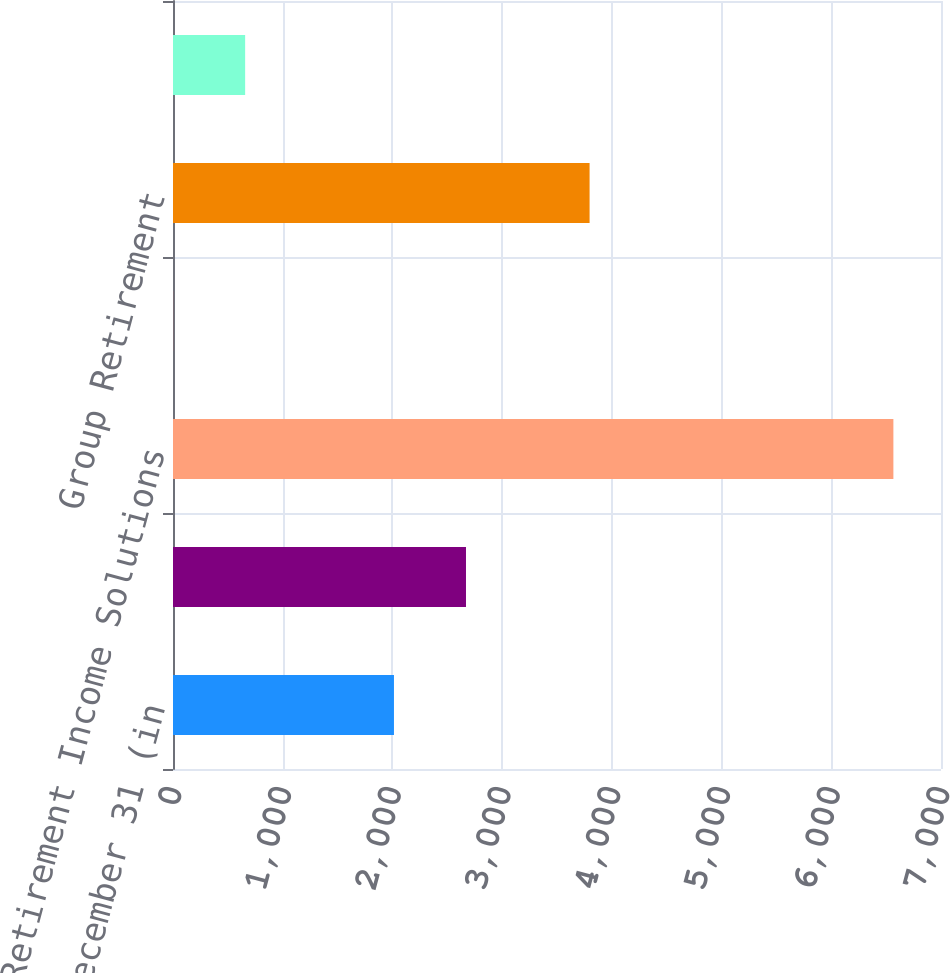Convert chart. <chart><loc_0><loc_0><loc_500><loc_500><bar_chart><fcel>Years Ended December 31 (in<fcel>Fixed Annuities<fcel>Retirement Income Solutions<fcel>Retail Mutual Funds<fcel>Group Retirement<fcel>Total Retirement net flows<nl><fcel>2014<fcel>2670.5<fcel>6566<fcel>1<fcel>3797<fcel>657.5<nl></chart> 